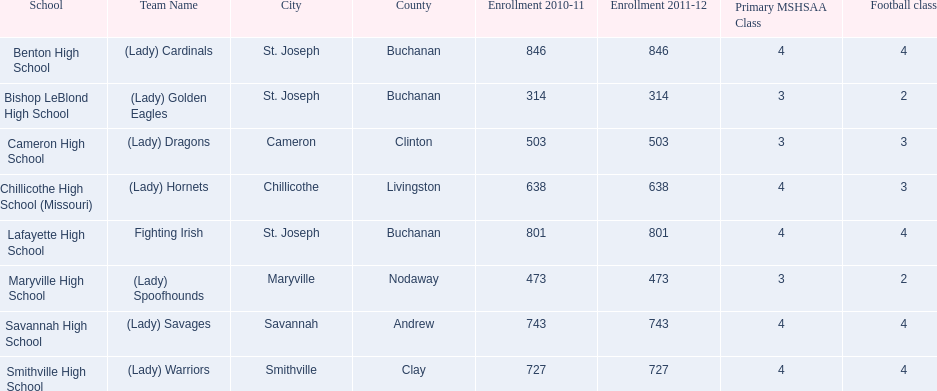What schools are located in st. joseph? Benton High School, Bishop LeBlond High School, Lafayette High School. Which st. joseph schools have more then 800 enrollment  for 2010-11 7 2011-12? Benton High School, Lafayette High School. What is the name of the st. joseph school with 800 or more enrollment's team names is a not a (lady)? Lafayette High School. 